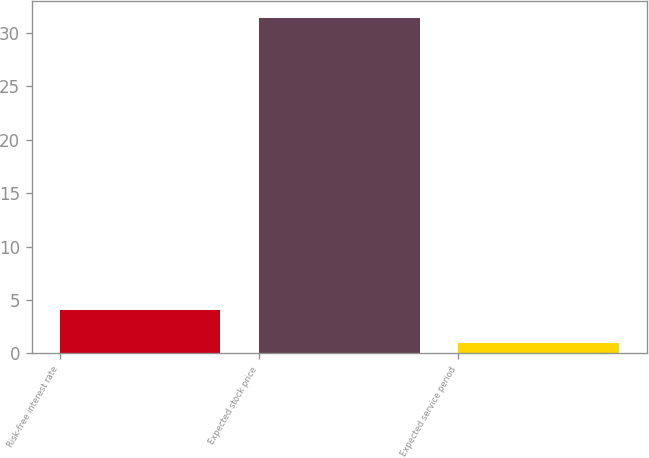<chart> <loc_0><loc_0><loc_500><loc_500><bar_chart><fcel>Risk-free interest rate<fcel>Expected stock price<fcel>Expected service period<nl><fcel>4.04<fcel>31.4<fcel>1<nl></chart> 